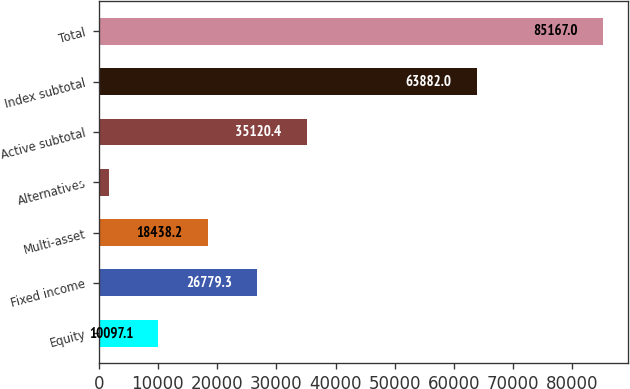Convert chart to OTSL. <chart><loc_0><loc_0><loc_500><loc_500><bar_chart><fcel>Equity<fcel>Fixed income<fcel>Multi-asset<fcel>Alternatives<fcel>Active subtotal<fcel>Index subtotal<fcel>Total<nl><fcel>10097.1<fcel>26779.3<fcel>18438.2<fcel>1756<fcel>35120.4<fcel>63882<fcel>85167<nl></chart> 